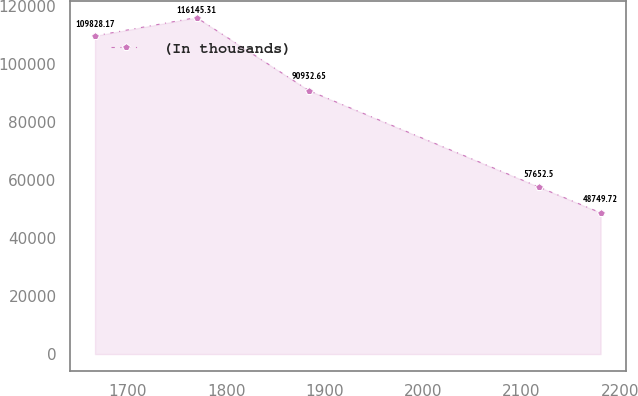<chart> <loc_0><loc_0><loc_500><loc_500><line_chart><ecel><fcel>(In thousands)<nl><fcel>1666.43<fcel>109828<nl><fcel>1769.7<fcel>116145<nl><fcel>1883.99<fcel>90932.6<nl><fcel>2117.85<fcel>57652.5<nl><fcel>2180.62<fcel>48749.7<nl></chart> 